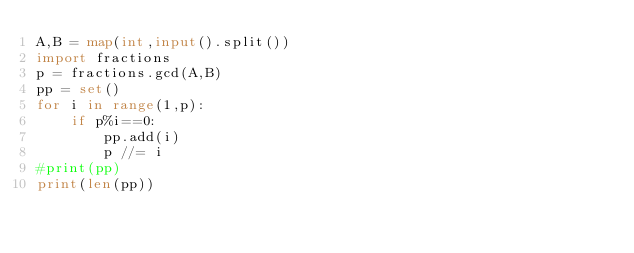<code> <loc_0><loc_0><loc_500><loc_500><_Python_>A,B = map(int,input().split())
import fractions
p = fractions.gcd(A,B)
pp = set()
for i in range(1,p):
    if p%i==0:
        pp.add(i)
        p //= i
#print(pp)
print(len(pp))</code> 